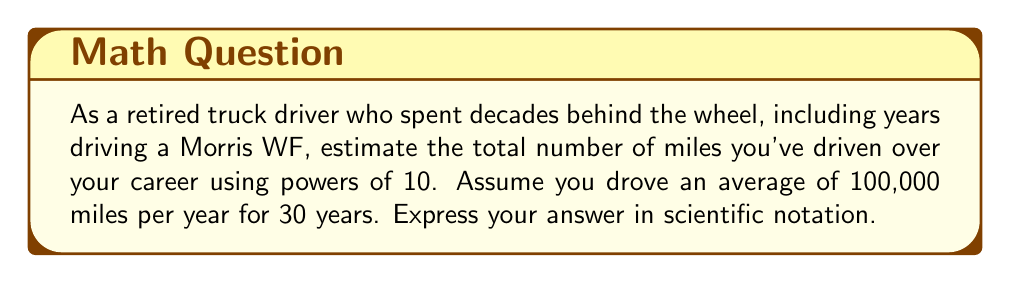Can you answer this question? Let's break this down step-by-step:

1) First, we need to calculate the total miles driven:
   Miles per year: 100,000
   Number of years: 30

2) To multiply these numbers, we can use the properties of exponents:
   $100,000 = 10^5$ (as 100,000 = 1 followed by 5 zeros)
   $30 = 3 \times 10^1$

3) Now, we multiply:
   $(10^5) \times (3 \times 10^1) = 3 \times 10^6$

4) This can be read as 3 million miles.

5) In scientific notation, this is already in the correct form: $3 \times 10^6$

Therefore, the estimated total number of miles driven over your 30-year career, expressed in scientific notation, is $3 \times 10^6$ miles.
Answer: $3 \times 10^6$ miles 